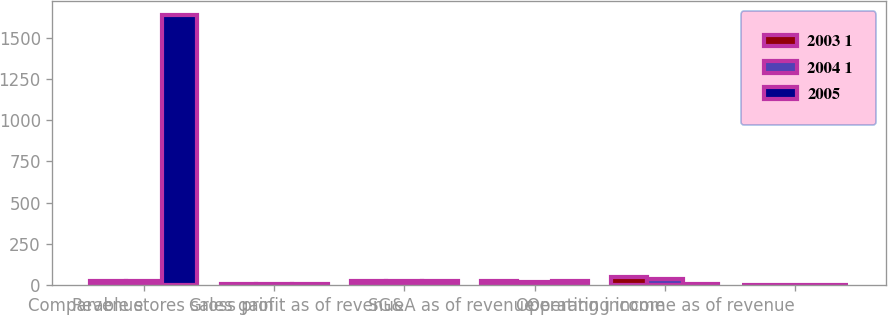Convert chart. <chart><loc_0><loc_0><loc_500><loc_500><stacked_bar_chart><ecel><fcel>Revenue<fcel>Comparable stores sales gain<fcel>Gross profit as of revenue<fcel>SG&A as of revenue<fcel>Operating income<fcel>Operating income as of revenue<nl><fcel>2003 1<fcel>20.65<fcel>3.3<fcel>22.5<fcel>20.7<fcel>49<fcel>1.7<nl><fcel>2004 1<fcel>20.65<fcel>4.7<fcel>22.2<fcel>20.6<fcel>37<fcel>1.6<nl><fcel>2005<fcel>1640<fcel>4.3<fcel>23<fcel>22.5<fcel>8<fcel>0.5<nl></chart> 